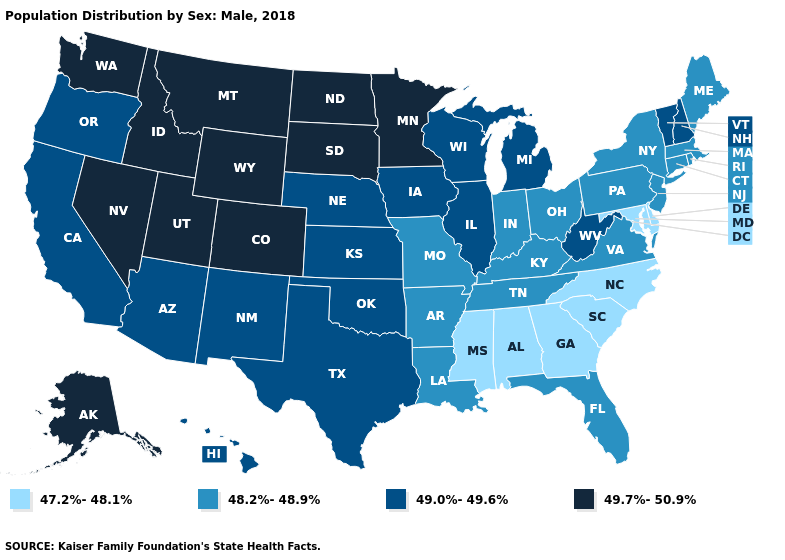What is the value of Connecticut?
Quick response, please. 48.2%-48.9%. Name the states that have a value in the range 47.2%-48.1%?
Short answer required. Alabama, Delaware, Georgia, Maryland, Mississippi, North Carolina, South Carolina. What is the value of New Jersey?
Write a very short answer. 48.2%-48.9%. What is the highest value in the USA?
Be succinct. 49.7%-50.9%. What is the value of Arkansas?
Be succinct. 48.2%-48.9%. Name the states that have a value in the range 49.7%-50.9%?
Quick response, please. Alaska, Colorado, Idaho, Minnesota, Montana, Nevada, North Dakota, South Dakota, Utah, Washington, Wyoming. Does New Jersey have the highest value in the USA?
Keep it brief. No. Does Massachusetts have the same value as Louisiana?
Quick response, please. Yes. Name the states that have a value in the range 48.2%-48.9%?
Write a very short answer. Arkansas, Connecticut, Florida, Indiana, Kentucky, Louisiana, Maine, Massachusetts, Missouri, New Jersey, New York, Ohio, Pennsylvania, Rhode Island, Tennessee, Virginia. What is the value of Arizona?
Write a very short answer. 49.0%-49.6%. What is the value of Illinois?
Write a very short answer. 49.0%-49.6%. Does Montana have a higher value than Washington?
Keep it brief. No. What is the value of South Carolina?
Short answer required. 47.2%-48.1%. What is the value of Mississippi?
Concise answer only. 47.2%-48.1%. What is the value of Maine?
Short answer required. 48.2%-48.9%. 